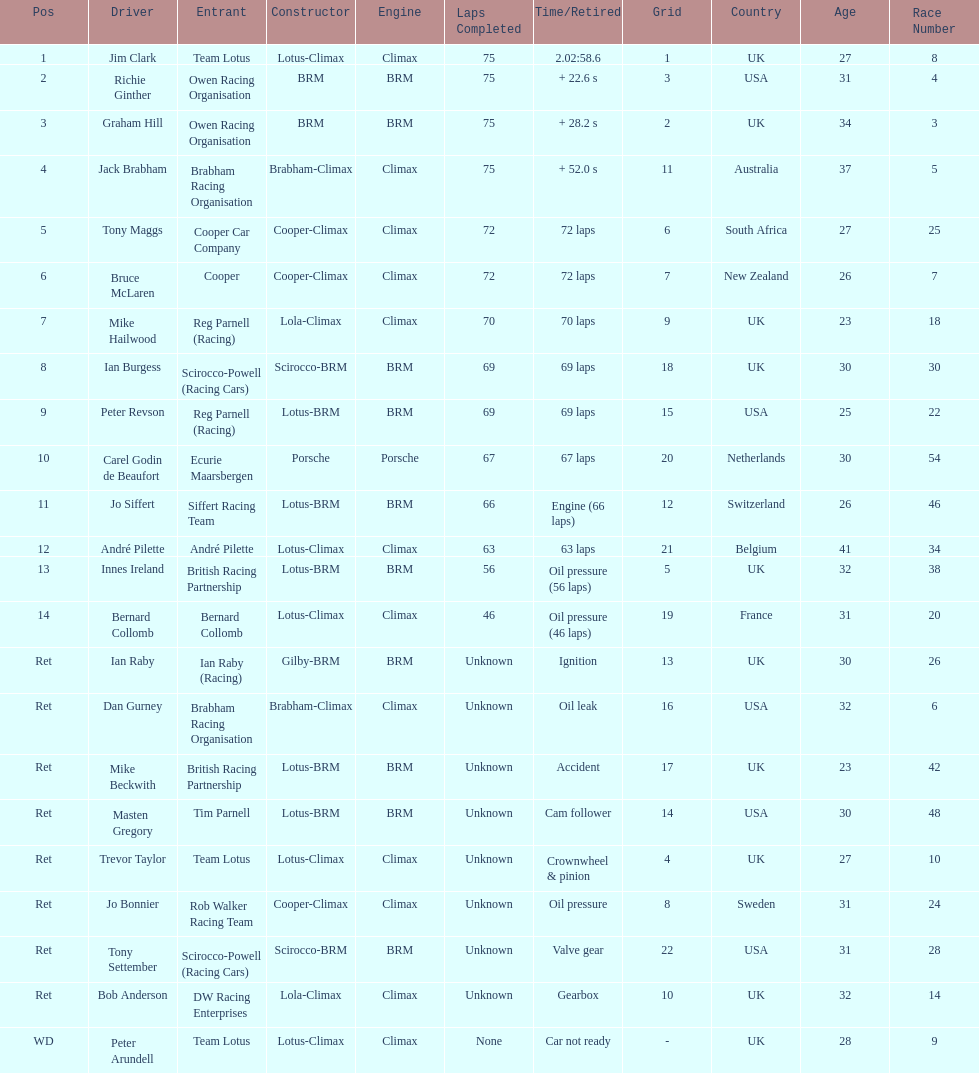What country had the least number of drivers, germany or the uk? Germany. 